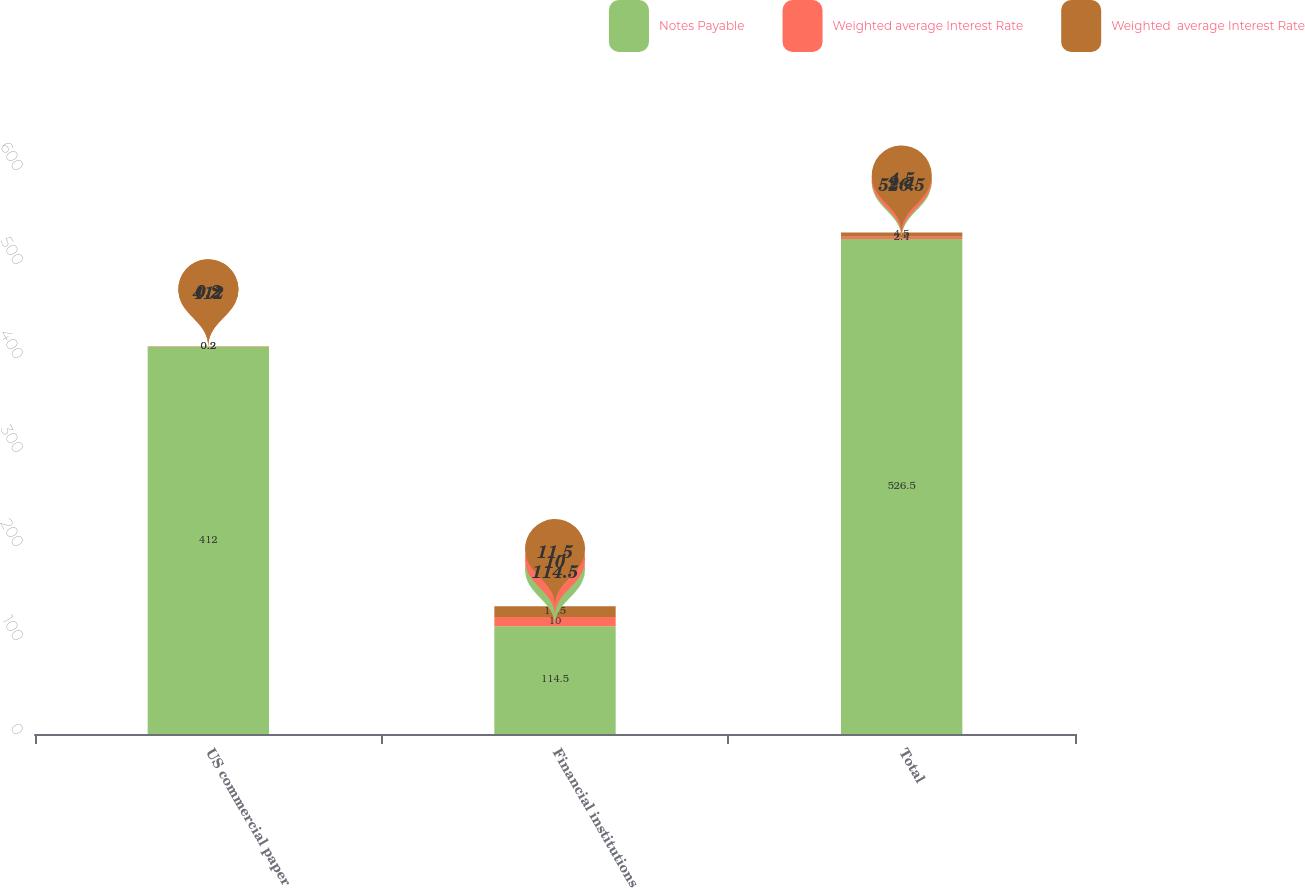Convert chart to OTSL. <chart><loc_0><loc_0><loc_500><loc_500><stacked_bar_chart><ecel><fcel>US commercial paper<fcel>Financial institutions<fcel>Total<nl><fcel>Notes Payable<fcel>412<fcel>114.5<fcel>526.5<nl><fcel>Weighted average Interest Rate<fcel>0.2<fcel>10<fcel>2.4<nl><fcel>Weighted  average Interest Rate<fcel>0.2<fcel>11.5<fcel>4.5<nl></chart> 